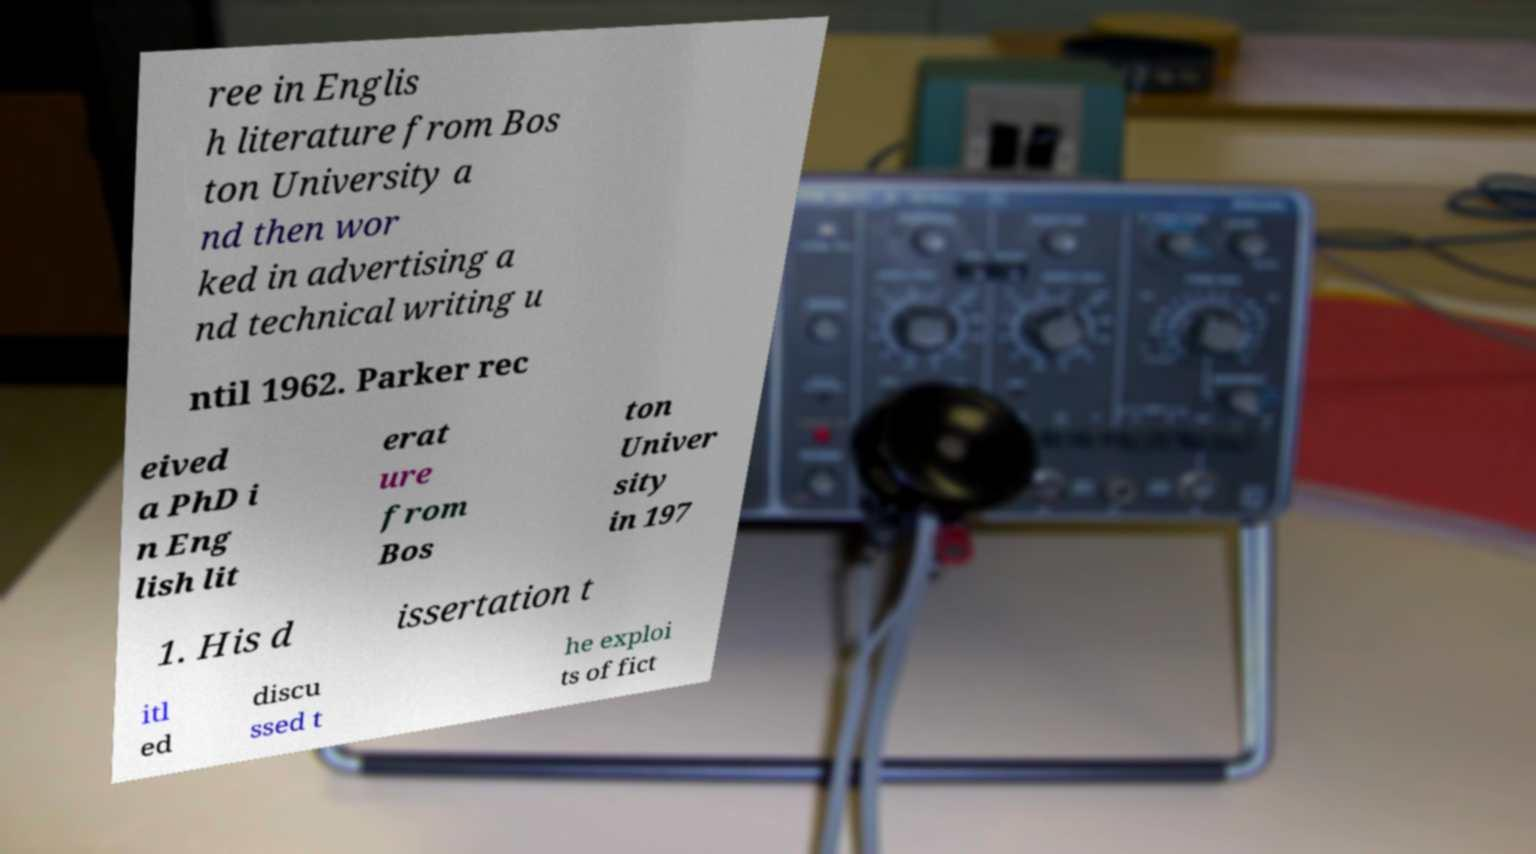Could you assist in decoding the text presented in this image and type it out clearly? ree in Englis h literature from Bos ton University a nd then wor ked in advertising a nd technical writing u ntil 1962. Parker rec eived a PhD i n Eng lish lit erat ure from Bos ton Univer sity in 197 1. His d issertation t itl ed discu ssed t he exploi ts of fict 